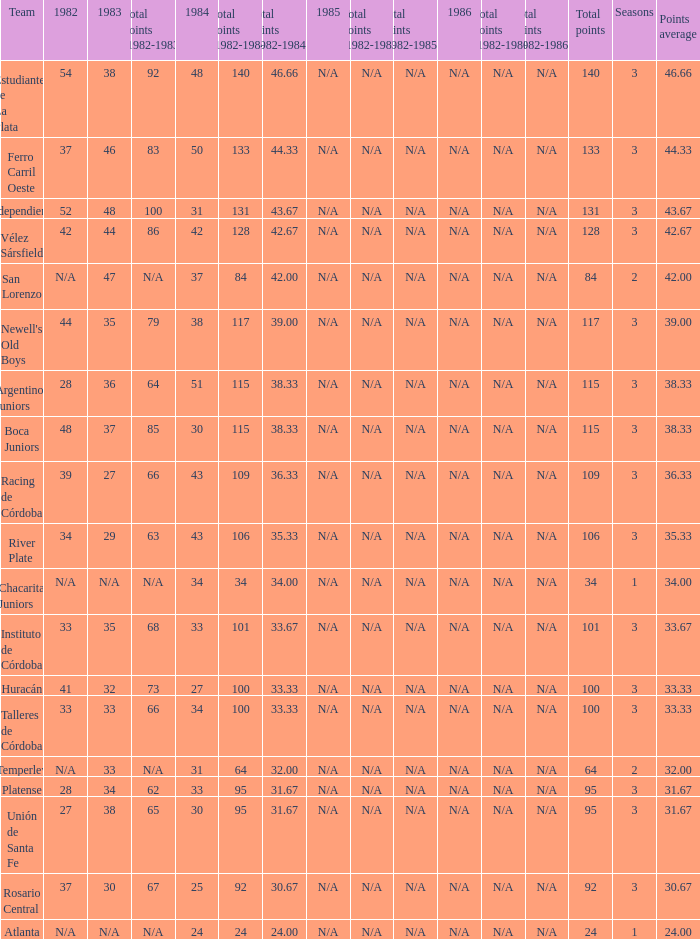What is the number of seasons for the team with a total fewer than 24? None. 